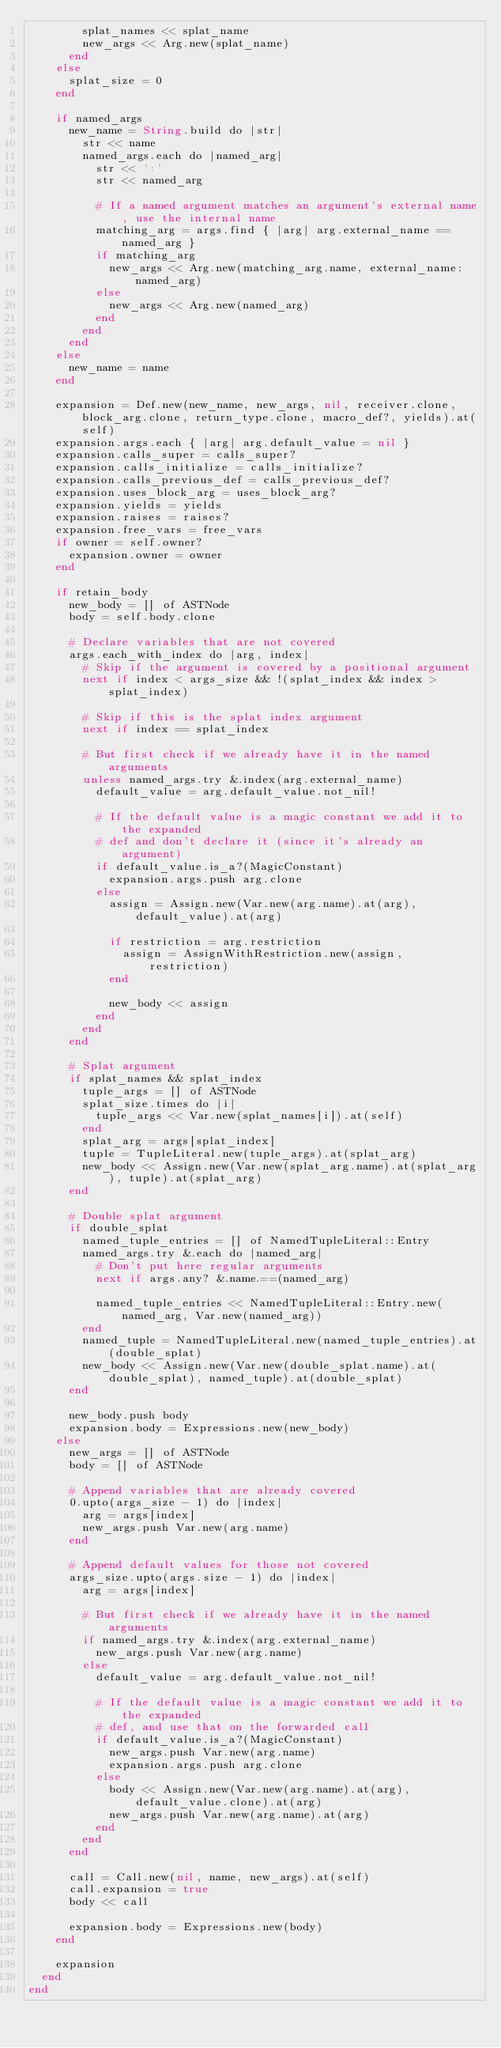Convert code to text. <code><loc_0><loc_0><loc_500><loc_500><_Crystal_>        splat_names << splat_name
        new_args << Arg.new(splat_name)
      end
    else
      splat_size = 0
    end

    if named_args
      new_name = String.build do |str|
        str << name
        named_args.each do |named_arg|
          str << ':'
          str << named_arg

          # If a named argument matches an argument's external name, use the internal name
          matching_arg = args.find { |arg| arg.external_name == named_arg }
          if matching_arg
            new_args << Arg.new(matching_arg.name, external_name: named_arg)
          else
            new_args << Arg.new(named_arg)
          end
        end
      end
    else
      new_name = name
    end

    expansion = Def.new(new_name, new_args, nil, receiver.clone, block_arg.clone, return_type.clone, macro_def?, yields).at(self)
    expansion.args.each { |arg| arg.default_value = nil }
    expansion.calls_super = calls_super?
    expansion.calls_initialize = calls_initialize?
    expansion.calls_previous_def = calls_previous_def?
    expansion.uses_block_arg = uses_block_arg?
    expansion.yields = yields
    expansion.raises = raises?
    expansion.free_vars = free_vars
    if owner = self.owner?
      expansion.owner = owner
    end

    if retain_body
      new_body = [] of ASTNode
      body = self.body.clone

      # Declare variables that are not covered
      args.each_with_index do |arg, index|
        # Skip if the argument is covered by a positional argument
        next if index < args_size && !(splat_index && index > splat_index)

        # Skip if this is the splat index argument
        next if index == splat_index

        # But first check if we already have it in the named arguments
        unless named_args.try &.index(arg.external_name)
          default_value = arg.default_value.not_nil!

          # If the default value is a magic constant we add it to the expanded
          # def and don't declare it (since it's already an argument)
          if default_value.is_a?(MagicConstant)
            expansion.args.push arg.clone
          else
            assign = Assign.new(Var.new(arg.name).at(arg), default_value).at(arg)

            if restriction = arg.restriction
              assign = AssignWithRestriction.new(assign, restriction)
            end

            new_body << assign
          end
        end
      end

      # Splat argument
      if splat_names && splat_index
        tuple_args = [] of ASTNode
        splat_size.times do |i|
          tuple_args << Var.new(splat_names[i]).at(self)
        end
        splat_arg = args[splat_index]
        tuple = TupleLiteral.new(tuple_args).at(splat_arg)
        new_body << Assign.new(Var.new(splat_arg.name).at(splat_arg), tuple).at(splat_arg)
      end

      # Double splat argument
      if double_splat
        named_tuple_entries = [] of NamedTupleLiteral::Entry
        named_args.try &.each do |named_arg|
          # Don't put here regular arguments
          next if args.any? &.name.==(named_arg)

          named_tuple_entries << NamedTupleLiteral::Entry.new(named_arg, Var.new(named_arg))
        end
        named_tuple = NamedTupleLiteral.new(named_tuple_entries).at(double_splat)
        new_body << Assign.new(Var.new(double_splat.name).at(double_splat), named_tuple).at(double_splat)
      end

      new_body.push body
      expansion.body = Expressions.new(new_body)
    else
      new_args = [] of ASTNode
      body = [] of ASTNode

      # Append variables that are already covered
      0.upto(args_size - 1) do |index|
        arg = args[index]
        new_args.push Var.new(arg.name)
      end

      # Append default values for those not covered
      args_size.upto(args.size - 1) do |index|
        arg = args[index]

        # But first check if we already have it in the named arguments
        if named_args.try &.index(arg.external_name)
          new_args.push Var.new(arg.name)
        else
          default_value = arg.default_value.not_nil!

          # If the default value is a magic constant we add it to the expanded
          # def, and use that on the forwarded call
          if default_value.is_a?(MagicConstant)
            new_args.push Var.new(arg.name)
            expansion.args.push arg.clone
          else
            body << Assign.new(Var.new(arg.name).at(arg), default_value.clone).at(arg)
            new_args.push Var.new(arg.name).at(arg)
          end
        end
      end

      call = Call.new(nil, name, new_args).at(self)
      call.expansion = true
      body << call

      expansion.body = Expressions.new(body)
    end

    expansion
  end
end
</code> 